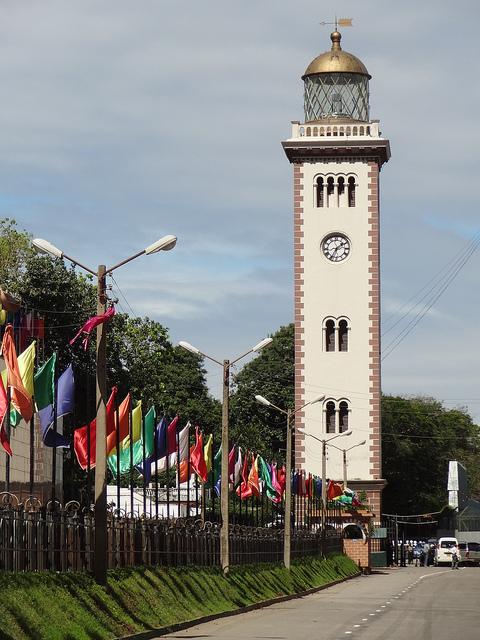How many flags can be seen?
Concise answer only. 30. Where is this?
Short answer required. London. Is this an intersection?
Keep it brief. No. What is the tall building?
Write a very short answer. Tower. 